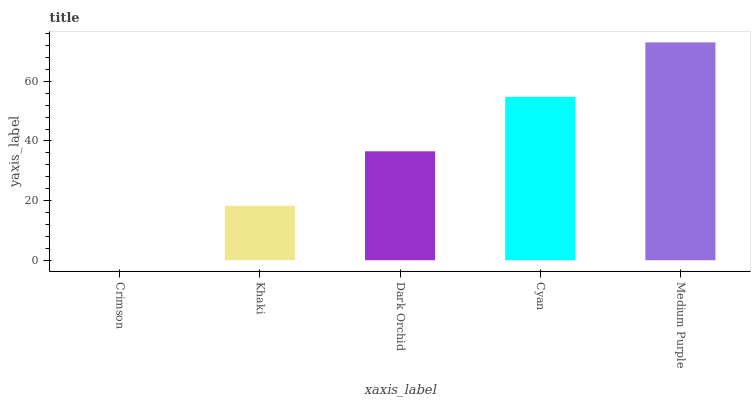Is Crimson the minimum?
Answer yes or no. Yes. Is Medium Purple the maximum?
Answer yes or no. Yes. Is Khaki the minimum?
Answer yes or no. No. Is Khaki the maximum?
Answer yes or no. No. Is Khaki greater than Crimson?
Answer yes or no. Yes. Is Crimson less than Khaki?
Answer yes or no. Yes. Is Crimson greater than Khaki?
Answer yes or no. No. Is Khaki less than Crimson?
Answer yes or no. No. Is Dark Orchid the high median?
Answer yes or no. Yes. Is Dark Orchid the low median?
Answer yes or no. Yes. Is Medium Purple the high median?
Answer yes or no. No. Is Cyan the low median?
Answer yes or no. No. 